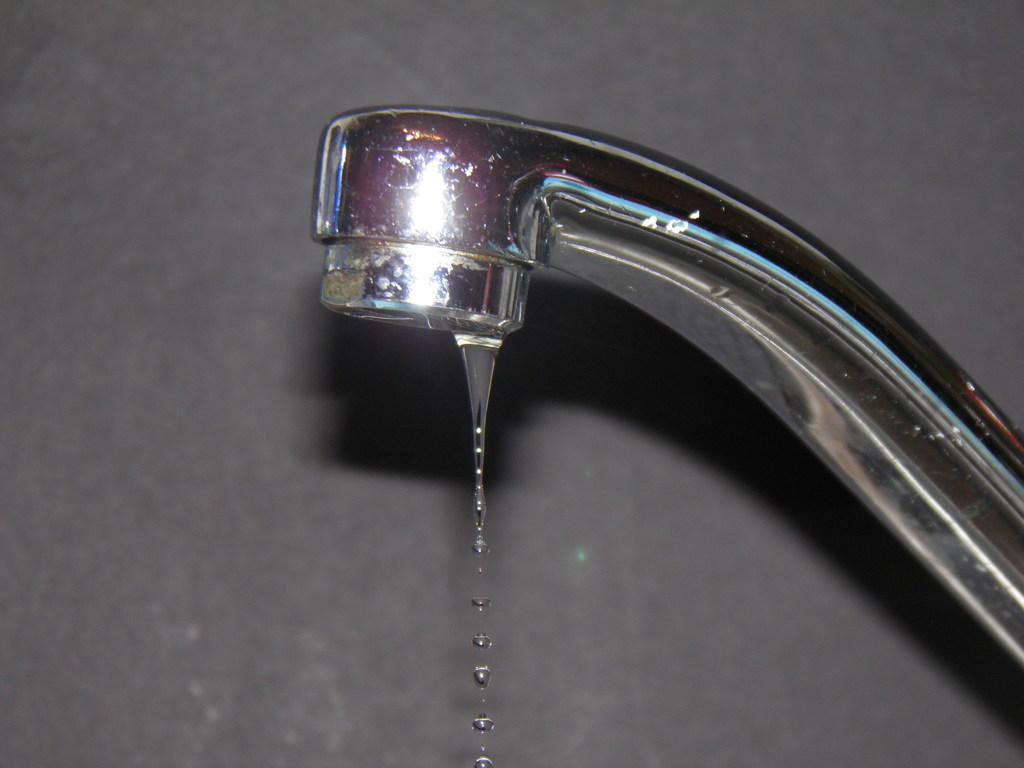In one or two sentences, can you explain what this image depicts? On the right side of the image we can see a tap. In the background there is a wall. 